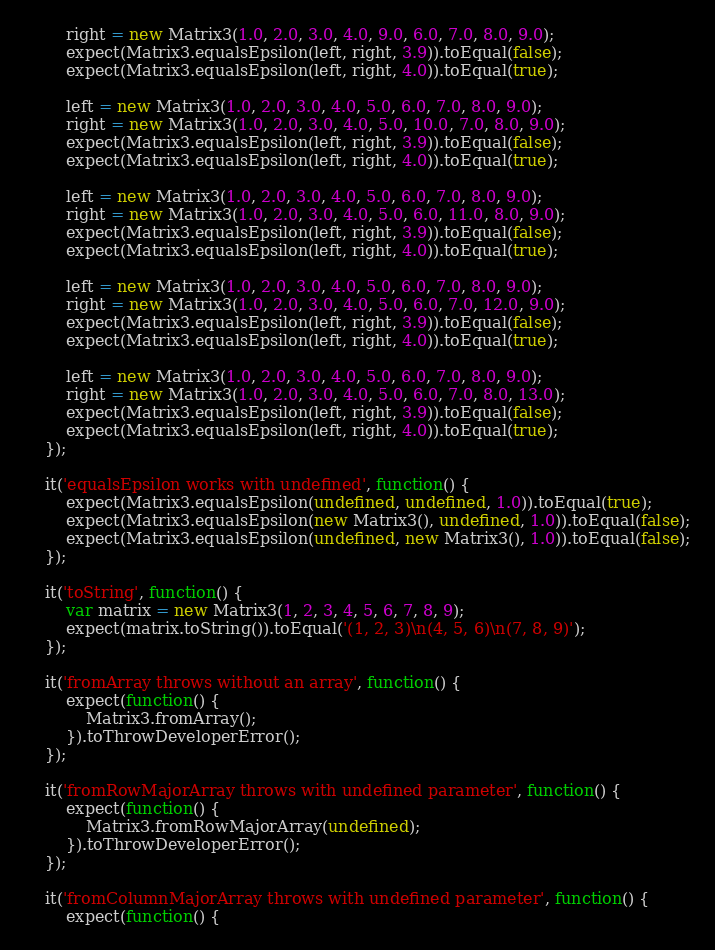<code> <loc_0><loc_0><loc_500><loc_500><_JavaScript_>        right = new Matrix3(1.0, 2.0, 3.0, 4.0, 9.0, 6.0, 7.0, 8.0, 9.0);
        expect(Matrix3.equalsEpsilon(left, right, 3.9)).toEqual(false);
        expect(Matrix3.equalsEpsilon(left, right, 4.0)).toEqual(true);

        left = new Matrix3(1.0, 2.0, 3.0, 4.0, 5.0, 6.0, 7.0, 8.0, 9.0);
        right = new Matrix3(1.0, 2.0, 3.0, 4.0, 5.0, 10.0, 7.0, 8.0, 9.0);
        expect(Matrix3.equalsEpsilon(left, right, 3.9)).toEqual(false);
        expect(Matrix3.equalsEpsilon(left, right, 4.0)).toEqual(true);

        left = new Matrix3(1.0, 2.0, 3.0, 4.0, 5.0, 6.0, 7.0, 8.0, 9.0);
        right = new Matrix3(1.0, 2.0, 3.0, 4.0, 5.0, 6.0, 11.0, 8.0, 9.0);
        expect(Matrix3.equalsEpsilon(left, right, 3.9)).toEqual(false);
        expect(Matrix3.equalsEpsilon(left, right, 4.0)).toEqual(true);

        left = new Matrix3(1.0, 2.0, 3.0, 4.0, 5.0, 6.0, 7.0, 8.0, 9.0);
        right = new Matrix3(1.0, 2.0, 3.0, 4.0, 5.0, 6.0, 7.0, 12.0, 9.0);
        expect(Matrix3.equalsEpsilon(left, right, 3.9)).toEqual(false);
        expect(Matrix3.equalsEpsilon(left, right, 4.0)).toEqual(true);

        left = new Matrix3(1.0, 2.0, 3.0, 4.0, 5.0, 6.0, 7.0, 8.0, 9.0);
        right = new Matrix3(1.0, 2.0, 3.0, 4.0, 5.0, 6.0, 7.0, 8.0, 13.0);
        expect(Matrix3.equalsEpsilon(left, right, 3.9)).toEqual(false);
        expect(Matrix3.equalsEpsilon(left, right, 4.0)).toEqual(true);
    });

    it('equalsEpsilon works with undefined', function() {
        expect(Matrix3.equalsEpsilon(undefined, undefined, 1.0)).toEqual(true);
        expect(Matrix3.equalsEpsilon(new Matrix3(), undefined, 1.0)).toEqual(false);
        expect(Matrix3.equalsEpsilon(undefined, new Matrix3(), 1.0)).toEqual(false);
    });

    it('toString', function() {
        var matrix = new Matrix3(1, 2, 3, 4, 5, 6, 7, 8, 9);
        expect(matrix.toString()).toEqual('(1, 2, 3)\n(4, 5, 6)\n(7, 8, 9)');
    });

    it('fromArray throws without an array', function() {
        expect(function() {
            Matrix3.fromArray();
        }).toThrowDeveloperError();
    });

    it('fromRowMajorArray throws with undefined parameter', function() {
        expect(function() {
            Matrix3.fromRowMajorArray(undefined);
        }).toThrowDeveloperError();
    });

    it('fromColumnMajorArray throws with undefined parameter', function() {
        expect(function() {</code> 